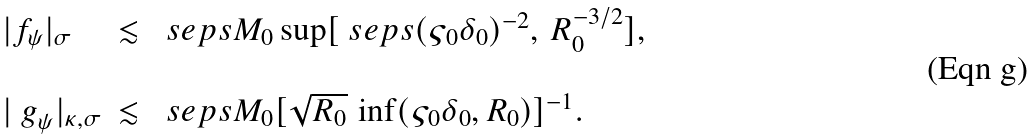<formula> <loc_0><loc_0><loc_500><loc_500>\begin{array} { l l l } | f _ { \psi } | _ { \sigma } & \lesssim & \ s e p s M _ { 0 } \sup [ \ s e p s ( \varsigma _ { 0 } \delta _ { 0 } ) ^ { - 2 } , \, R _ { 0 } ^ { - 3 / 2 } ] , \\ \\ | { \ g } _ { \psi } | _ { \kappa , \sigma } & \lesssim & \ s e p s M _ { 0 } [ \sqrt { R _ { 0 } } \, \inf ( \varsigma _ { 0 } \delta _ { 0 } , R _ { 0 } ) ] ^ { - 1 } . \end{array}</formula> 